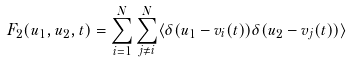<formula> <loc_0><loc_0><loc_500><loc_500>F _ { 2 } ( u _ { 1 } , u _ { 2 } , t ) = \sum _ { i = 1 } ^ { N } \sum _ { j \neq i } ^ { N } \langle \delta ( u _ { 1 } - v _ { i } ( t ) ) \delta ( u _ { 2 } - v _ { j } ( t ) ) \rangle</formula> 